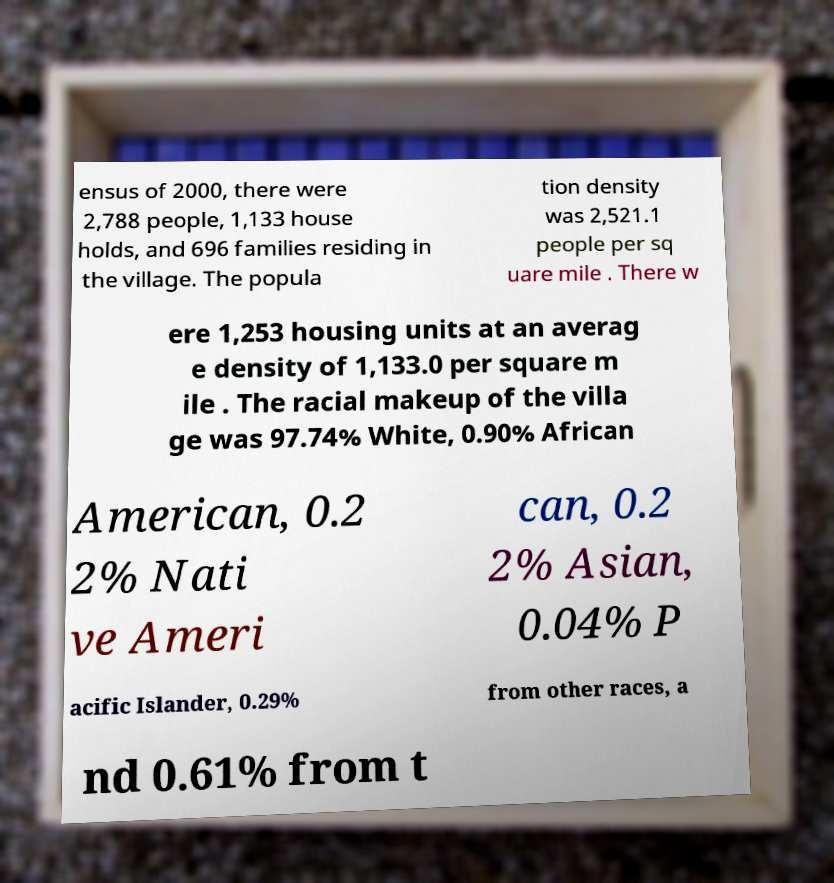Please identify and transcribe the text found in this image. ensus of 2000, there were 2,788 people, 1,133 house holds, and 696 families residing in the village. The popula tion density was 2,521.1 people per sq uare mile . There w ere 1,253 housing units at an averag e density of 1,133.0 per square m ile . The racial makeup of the villa ge was 97.74% White, 0.90% African American, 0.2 2% Nati ve Ameri can, 0.2 2% Asian, 0.04% P acific Islander, 0.29% from other races, a nd 0.61% from t 